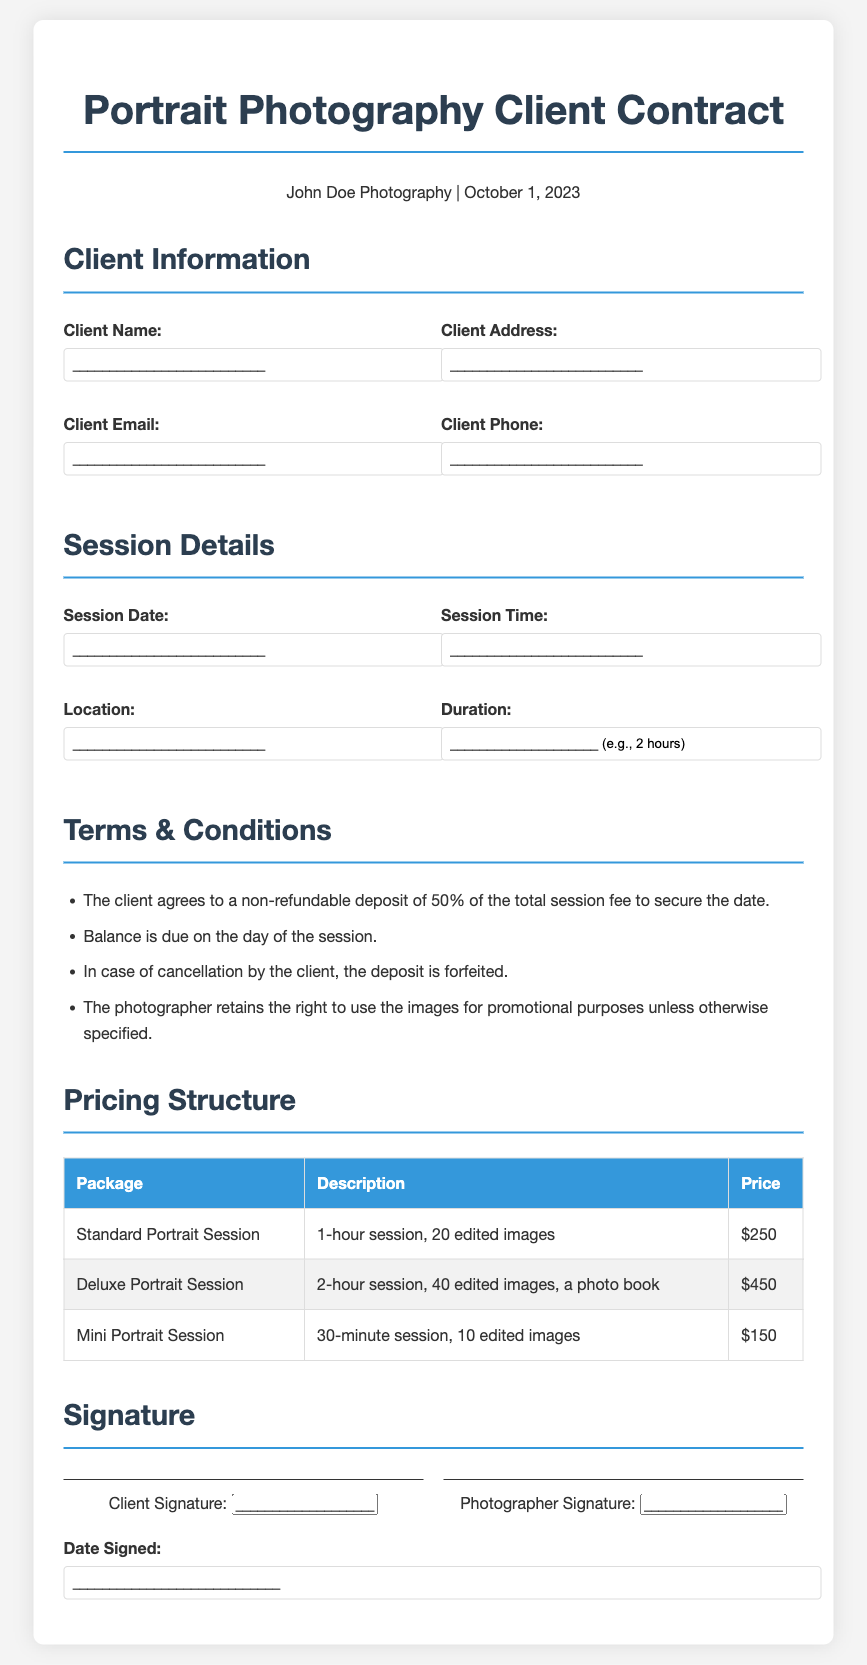What is the client's name? The client's name is a placeholder in the document, represented as an input field.
Answer: __________________________ What is the non-refundable deposit percentage? The document states the non-refundable deposit is 50% of the total session fee.
Answer: 50% What is the price of the Deluxe Portrait Session? The pricing structure lists the Deluxe Portrait Session price explicitly.
Answer: $450 When is the contract dated? The document specifies the date as October 1, 2023.
Answer: October 1, 2023 What is the duration of the Standard Portrait Session? The Standard Portrait Session duration is mentioned in the pricing structure.
Answer: 1 hour What happens if the client cancels the session? The terms state that the deposit is forfeited if the client cancels.
Answer: Deposit is forfeited What is included in the Mini Portrait Session? The document outlines what is included in the Mini Portrait Session.
Answer: 30-minute session, 10 edited images How many edited images does the Deluxe Portrait Session include? The pricing structure provides details on the number of edited images.
Answer: 40 edited images What signatures are required at the end of the contract? The signature section specifies the required signatures explicitly.
Answer: Client Signature, Photographer Signature 